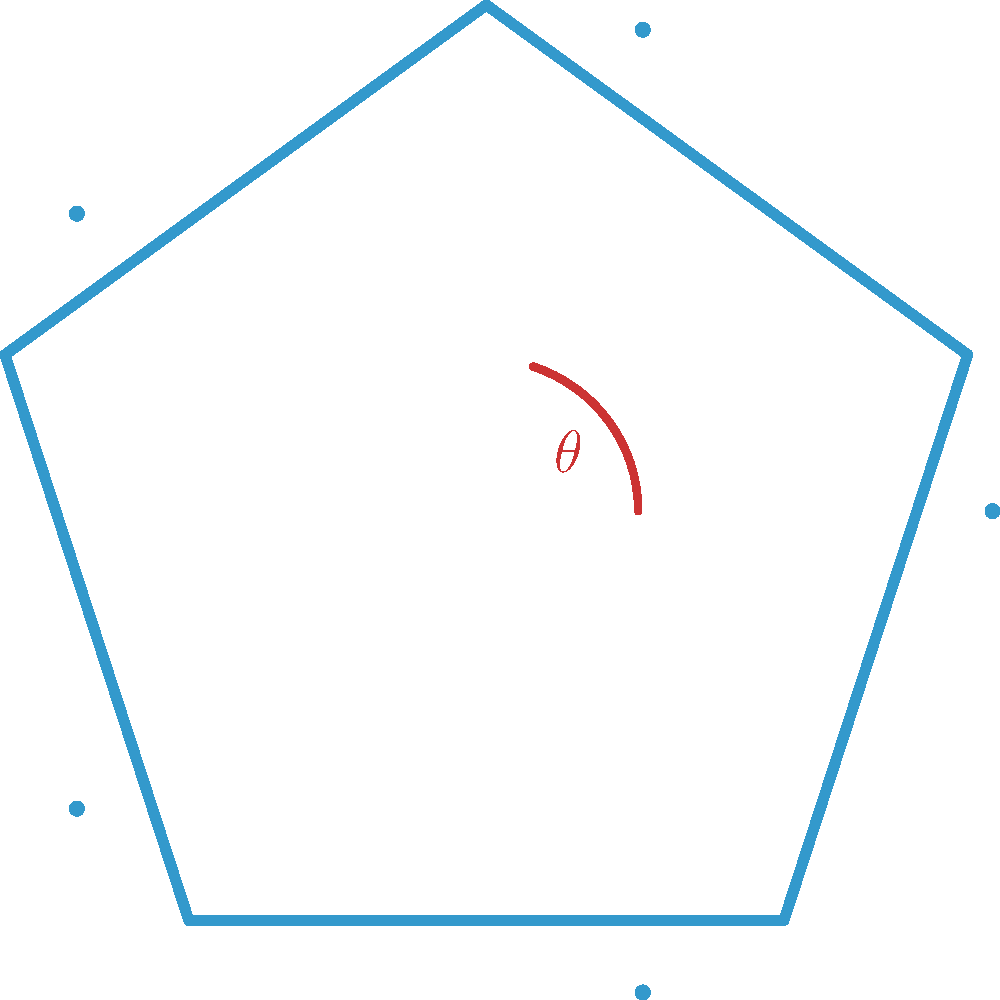In designing a logo for Tiki Groupware, you've decided to use a regular pentagon as the base shape. If $\theta$ represents one of the interior angles of this pentagon, what is the value of $\theta$ in degrees? Let's approach this step-by-step:

1) First, recall the formula for the sum of interior angles of any polygon with $n$ sides:
   $S = (n-2) \times 180°$

2) For a pentagon, $n = 5$, so:
   $S = (5-2) \times 180° = 3 \times 180° = 540°$

3) In a regular polygon, all interior angles are equal. To find one angle, we divide the sum by the number of angles:
   $\theta = \frac{S}{n} = \frac{540°}{5} = 108°$

4) We can verify this using another method. The formula for one interior angle of a regular polygon is:
   $\theta = \frac{(n-2) \times 180°}{n} = \frac{(5-2) \times 180°}{5} = \frac{540°}{5} = 108°$

Therefore, each interior angle of the regular pentagon in the Tiki Groupware logo is 108°.
Answer: 108° 